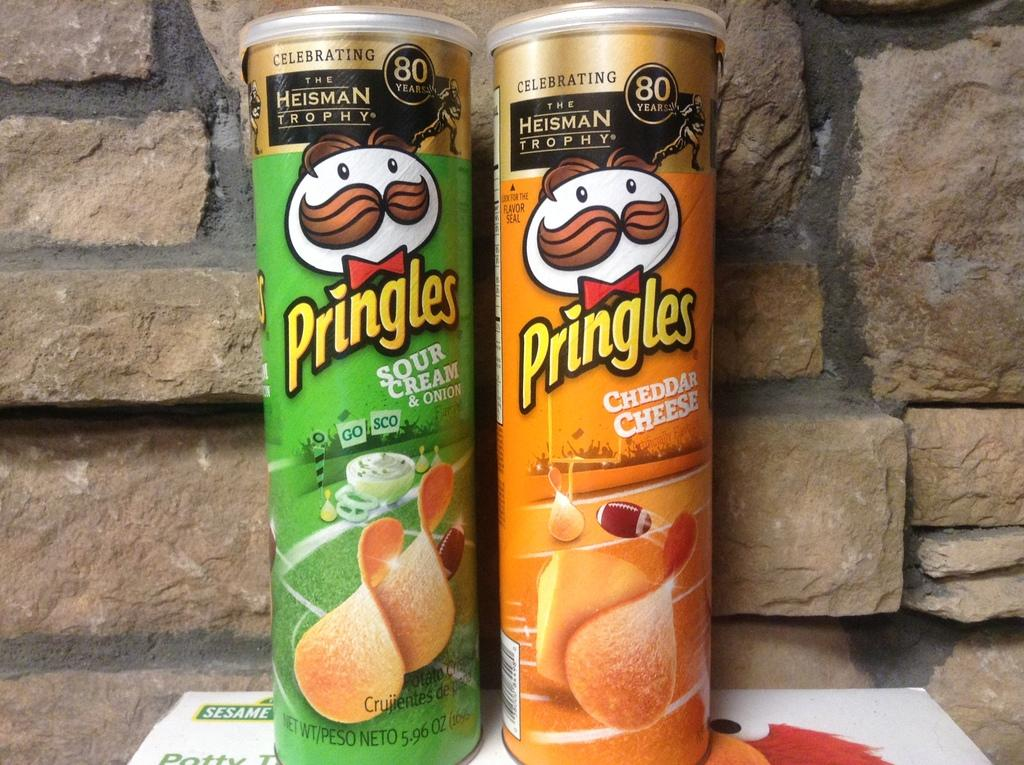How many boxes are in the image? There are two cylindrical shaped boxes in the image. What colors are the boxes? One box is green in color, and the other box is orange in color. What can be seen in the background of the image? There is a stone wall in the background of the image. How does hope manifest itself in the image? The concept of hope is not present in the image, as it features two cylindrical shaped boxes and a stone wall in the background. 